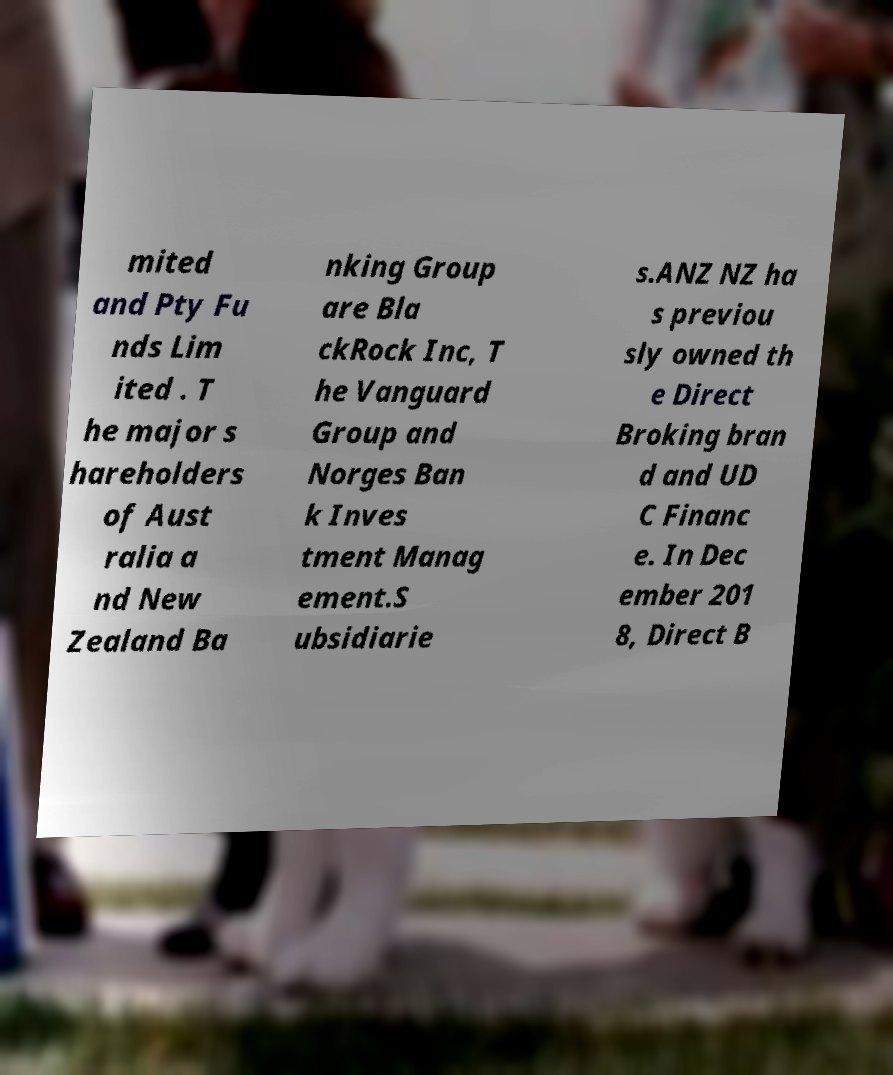Please identify and transcribe the text found in this image. mited and Pty Fu nds Lim ited . T he major s hareholders of Aust ralia a nd New Zealand Ba nking Group are Bla ckRock Inc, T he Vanguard Group and Norges Ban k Inves tment Manag ement.S ubsidiarie s.ANZ NZ ha s previou sly owned th e Direct Broking bran d and UD C Financ e. In Dec ember 201 8, Direct B 